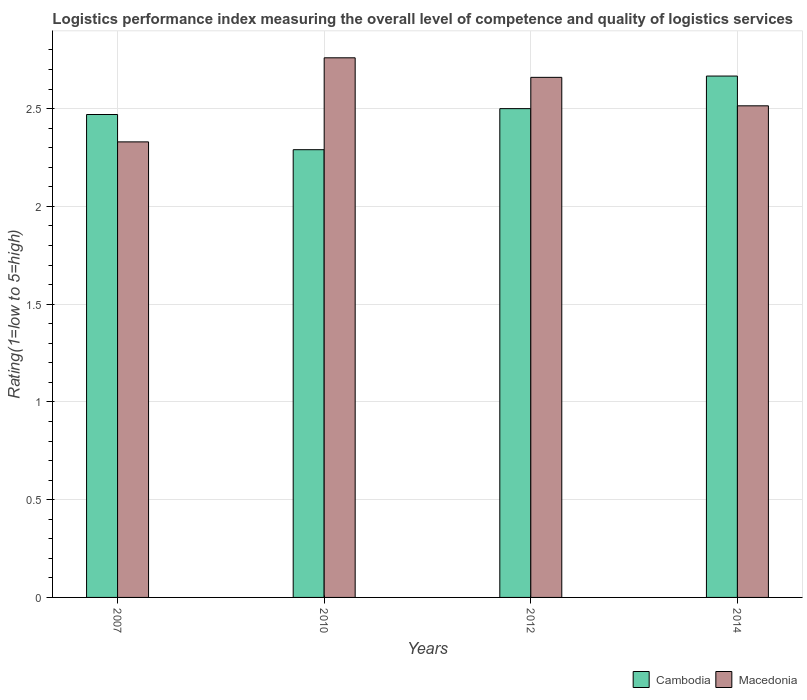Are the number of bars on each tick of the X-axis equal?
Provide a succinct answer. Yes. How many bars are there on the 4th tick from the left?
Provide a short and direct response. 2. What is the Logistic performance index in Macedonia in 2007?
Keep it short and to the point. 2.33. Across all years, what is the maximum Logistic performance index in Cambodia?
Provide a succinct answer. 2.67. Across all years, what is the minimum Logistic performance index in Macedonia?
Ensure brevity in your answer.  2.33. In which year was the Logistic performance index in Macedonia minimum?
Your answer should be compact. 2007. What is the total Logistic performance index in Cambodia in the graph?
Provide a succinct answer. 9.93. What is the difference between the Logistic performance index in Macedonia in 2007 and that in 2010?
Ensure brevity in your answer.  -0.43. What is the difference between the Logistic performance index in Macedonia in 2007 and the Logistic performance index in Cambodia in 2014?
Your response must be concise. -0.34. What is the average Logistic performance index in Macedonia per year?
Keep it short and to the point. 2.57. In the year 2010, what is the difference between the Logistic performance index in Cambodia and Logistic performance index in Macedonia?
Your answer should be compact. -0.47. What is the ratio of the Logistic performance index in Macedonia in 2012 to that in 2014?
Offer a very short reply. 1.06. Is the Logistic performance index in Cambodia in 2007 less than that in 2010?
Provide a succinct answer. No. What is the difference between the highest and the second highest Logistic performance index in Cambodia?
Ensure brevity in your answer.  0.17. What is the difference between the highest and the lowest Logistic performance index in Cambodia?
Make the answer very short. 0.38. In how many years, is the Logistic performance index in Macedonia greater than the average Logistic performance index in Macedonia taken over all years?
Your answer should be very brief. 2. Is the sum of the Logistic performance index in Cambodia in 2012 and 2014 greater than the maximum Logistic performance index in Macedonia across all years?
Give a very brief answer. Yes. What does the 2nd bar from the left in 2007 represents?
Your answer should be compact. Macedonia. What does the 2nd bar from the right in 2014 represents?
Ensure brevity in your answer.  Cambodia. Are all the bars in the graph horizontal?
Keep it short and to the point. No. How many years are there in the graph?
Your answer should be compact. 4. What is the difference between two consecutive major ticks on the Y-axis?
Offer a very short reply. 0.5. Are the values on the major ticks of Y-axis written in scientific E-notation?
Provide a succinct answer. No. What is the title of the graph?
Keep it short and to the point. Logistics performance index measuring the overall level of competence and quality of logistics services. What is the label or title of the Y-axis?
Provide a short and direct response. Rating(1=low to 5=high). What is the Rating(1=low to 5=high) in Cambodia in 2007?
Provide a succinct answer. 2.47. What is the Rating(1=low to 5=high) in Macedonia in 2007?
Your answer should be very brief. 2.33. What is the Rating(1=low to 5=high) of Cambodia in 2010?
Offer a very short reply. 2.29. What is the Rating(1=low to 5=high) in Macedonia in 2010?
Offer a terse response. 2.76. What is the Rating(1=low to 5=high) in Macedonia in 2012?
Give a very brief answer. 2.66. What is the Rating(1=low to 5=high) in Cambodia in 2014?
Make the answer very short. 2.67. What is the Rating(1=low to 5=high) in Macedonia in 2014?
Offer a very short reply. 2.51. Across all years, what is the maximum Rating(1=low to 5=high) of Cambodia?
Ensure brevity in your answer.  2.67. Across all years, what is the maximum Rating(1=low to 5=high) of Macedonia?
Your answer should be very brief. 2.76. Across all years, what is the minimum Rating(1=low to 5=high) of Cambodia?
Give a very brief answer. 2.29. Across all years, what is the minimum Rating(1=low to 5=high) of Macedonia?
Keep it short and to the point. 2.33. What is the total Rating(1=low to 5=high) of Cambodia in the graph?
Provide a short and direct response. 9.93. What is the total Rating(1=low to 5=high) of Macedonia in the graph?
Give a very brief answer. 10.26. What is the difference between the Rating(1=low to 5=high) of Cambodia in 2007 and that in 2010?
Give a very brief answer. 0.18. What is the difference between the Rating(1=low to 5=high) of Macedonia in 2007 and that in 2010?
Keep it short and to the point. -0.43. What is the difference between the Rating(1=low to 5=high) of Cambodia in 2007 and that in 2012?
Offer a terse response. -0.03. What is the difference between the Rating(1=low to 5=high) in Macedonia in 2007 and that in 2012?
Provide a succinct answer. -0.33. What is the difference between the Rating(1=low to 5=high) in Cambodia in 2007 and that in 2014?
Offer a very short reply. -0.2. What is the difference between the Rating(1=low to 5=high) in Macedonia in 2007 and that in 2014?
Give a very brief answer. -0.18. What is the difference between the Rating(1=low to 5=high) of Cambodia in 2010 and that in 2012?
Make the answer very short. -0.21. What is the difference between the Rating(1=low to 5=high) of Cambodia in 2010 and that in 2014?
Offer a terse response. -0.38. What is the difference between the Rating(1=low to 5=high) of Macedonia in 2010 and that in 2014?
Keep it short and to the point. 0.25. What is the difference between the Rating(1=low to 5=high) of Cambodia in 2012 and that in 2014?
Make the answer very short. -0.17. What is the difference between the Rating(1=low to 5=high) of Macedonia in 2012 and that in 2014?
Provide a succinct answer. 0.15. What is the difference between the Rating(1=low to 5=high) in Cambodia in 2007 and the Rating(1=low to 5=high) in Macedonia in 2010?
Keep it short and to the point. -0.29. What is the difference between the Rating(1=low to 5=high) of Cambodia in 2007 and the Rating(1=low to 5=high) of Macedonia in 2012?
Provide a succinct answer. -0.19. What is the difference between the Rating(1=low to 5=high) in Cambodia in 2007 and the Rating(1=low to 5=high) in Macedonia in 2014?
Keep it short and to the point. -0.04. What is the difference between the Rating(1=low to 5=high) of Cambodia in 2010 and the Rating(1=low to 5=high) of Macedonia in 2012?
Offer a very short reply. -0.37. What is the difference between the Rating(1=low to 5=high) of Cambodia in 2010 and the Rating(1=low to 5=high) of Macedonia in 2014?
Provide a short and direct response. -0.22. What is the difference between the Rating(1=low to 5=high) of Cambodia in 2012 and the Rating(1=low to 5=high) of Macedonia in 2014?
Ensure brevity in your answer.  -0.01. What is the average Rating(1=low to 5=high) in Cambodia per year?
Offer a terse response. 2.48. What is the average Rating(1=low to 5=high) in Macedonia per year?
Give a very brief answer. 2.57. In the year 2007, what is the difference between the Rating(1=low to 5=high) of Cambodia and Rating(1=low to 5=high) of Macedonia?
Ensure brevity in your answer.  0.14. In the year 2010, what is the difference between the Rating(1=low to 5=high) of Cambodia and Rating(1=low to 5=high) of Macedonia?
Offer a terse response. -0.47. In the year 2012, what is the difference between the Rating(1=low to 5=high) of Cambodia and Rating(1=low to 5=high) of Macedonia?
Ensure brevity in your answer.  -0.16. In the year 2014, what is the difference between the Rating(1=low to 5=high) of Cambodia and Rating(1=low to 5=high) of Macedonia?
Offer a terse response. 0.15. What is the ratio of the Rating(1=low to 5=high) in Cambodia in 2007 to that in 2010?
Provide a succinct answer. 1.08. What is the ratio of the Rating(1=low to 5=high) in Macedonia in 2007 to that in 2010?
Your answer should be compact. 0.84. What is the ratio of the Rating(1=low to 5=high) in Macedonia in 2007 to that in 2012?
Offer a very short reply. 0.88. What is the ratio of the Rating(1=low to 5=high) of Cambodia in 2007 to that in 2014?
Offer a terse response. 0.93. What is the ratio of the Rating(1=low to 5=high) in Macedonia in 2007 to that in 2014?
Offer a very short reply. 0.93. What is the ratio of the Rating(1=low to 5=high) of Cambodia in 2010 to that in 2012?
Keep it short and to the point. 0.92. What is the ratio of the Rating(1=low to 5=high) of Macedonia in 2010 to that in 2012?
Offer a terse response. 1.04. What is the ratio of the Rating(1=low to 5=high) of Cambodia in 2010 to that in 2014?
Make the answer very short. 0.86. What is the ratio of the Rating(1=low to 5=high) in Macedonia in 2010 to that in 2014?
Offer a terse response. 1.1. What is the ratio of the Rating(1=low to 5=high) in Cambodia in 2012 to that in 2014?
Provide a succinct answer. 0.94. What is the ratio of the Rating(1=low to 5=high) in Macedonia in 2012 to that in 2014?
Ensure brevity in your answer.  1.06. What is the difference between the highest and the second highest Rating(1=low to 5=high) of Cambodia?
Offer a very short reply. 0.17. What is the difference between the highest and the lowest Rating(1=low to 5=high) in Cambodia?
Keep it short and to the point. 0.38. What is the difference between the highest and the lowest Rating(1=low to 5=high) of Macedonia?
Your answer should be very brief. 0.43. 